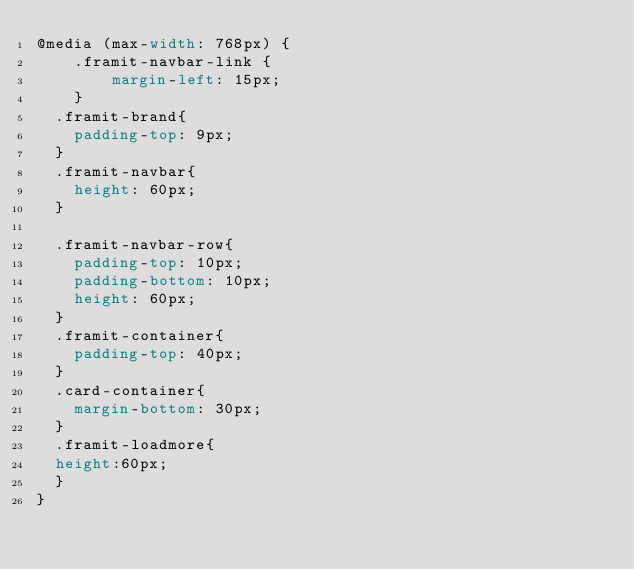Convert code to text. <code><loc_0><loc_0><loc_500><loc_500><_CSS_>@media (max-width: 768px) {
	.framit-navbar-link {
		margin-left: 15px;
	}
  .framit-brand{
    padding-top: 9px;
  }
  .framit-navbar{
    height: 60px;
  }

  .framit-navbar-row{
    padding-top: 10px;
    padding-bottom: 10px;
    height: 60px;
  }
  .framit-container{
    padding-top: 40px;
  }
  .card-container{
    margin-bottom: 30px;
  }
  .framit-loadmore{
  height:60px;
  }
}</code> 